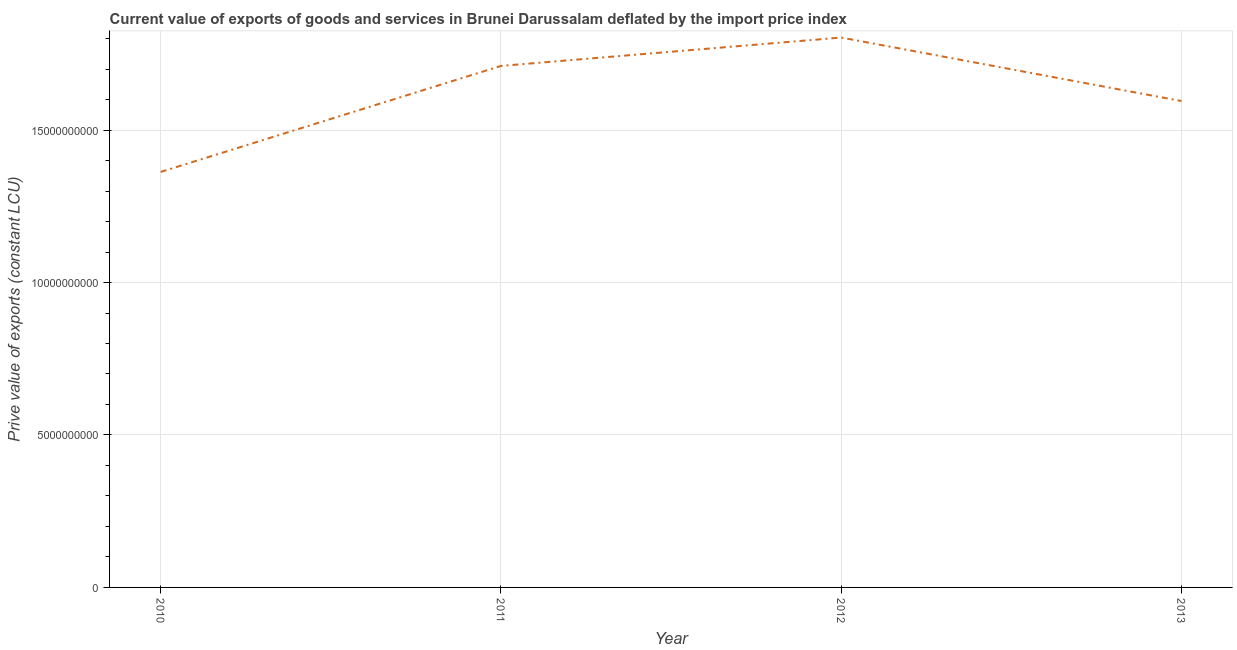What is the price value of exports in 2012?
Ensure brevity in your answer.  1.80e+1. Across all years, what is the maximum price value of exports?
Your answer should be compact. 1.80e+1. Across all years, what is the minimum price value of exports?
Provide a short and direct response. 1.36e+1. In which year was the price value of exports maximum?
Your response must be concise. 2012. In which year was the price value of exports minimum?
Keep it short and to the point. 2010. What is the sum of the price value of exports?
Keep it short and to the point. 6.47e+1. What is the difference between the price value of exports in 2011 and 2012?
Keep it short and to the point. -9.31e+08. What is the average price value of exports per year?
Your answer should be very brief. 1.62e+1. What is the median price value of exports?
Your answer should be compact. 1.65e+1. In how many years, is the price value of exports greater than 1000000000 LCU?
Offer a terse response. 4. What is the ratio of the price value of exports in 2010 to that in 2013?
Your answer should be very brief. 0.85. Is the price value of exports in 2010 less than that in 2013?
Ensure brevity in your answer.  Yes. Is the difference between the price value of exports in 2011 and 2013 greater than the difference between any two years?
Your answer should be compact. No. What is the difference between the highest and the second highest price value of exports?
Offer a very short reply. 9.31e+08. What is the difference between the highest and the lowest price value of exports?
Make the answer very short. 4.41e+09. In how many years, is the price value of exports greater than the average price value of exports taken over all years?
Your answer should be very brief. 2. How many lines are there?
Your response must be concise. 1. What is the difference between two consecutive major ticks on the Y-axis?
Provide a succinct answer. 5.00e+09. Are the values on the major ticks of Y-axis written in scientific E-notation?
Ensure brevity in your answer.  No. Does the graph contain any zero values?
Offer a very short reply. No. Does the graph contain grids?
Make the answer very short. Yes. What is the title of the graph?
Your response must be concise. Current value of exports of goods and services in Brunei Darussalam deflated by the import price index. What is the label or title of the X-axis?
Your answer should be very brief. Year. What is the label or title of the Y-axis?
Offer a very short reply. Prive value of exports (constant LCU). What is the Prive value of exports (constant LCU) of 2010?
Give a very brief answer. 1.36e+1. What is the Prive value of exports (constant LCU) in 2011?
Keep it short and to the point. 1.71e+1. What is the Prive value of exports (constant LCU) in 2012?
Your response must be concise. 1.80e+1. What is the Prive value of exports (constant LCU) of 2013?
Ensure brevity in your answer.  1.60e+1. What is the difference between the Prive value of exports (constant LCU) in 2010 and 2011?
Keep it short and to the point. -3.48e+09. What is the difference between the Prive value of exports (constant LCU) in 2010 and 2012?
Make the answer very short. -4.41e+09. What is the difference between the Prive value of exports (constant LCU) in 2010 and 2013?
Keep it short and to the point. -2.33e+09. What is the difference between the Prive value of exports (constant LCU) in 2011 and 2012?
Offer a very short reply. -9.31e+08. What is the difference between the Prive value of exports (constant LCU) in 2011 and 2013?
Provide a succinct answer. 1.15e+09. What is the difference between the Prive value of exports (constant LCU) in 2012 and 2013?
Ensure brevity in your answer.  2.08e+09. What is the ratio of the Prive value of exports (constant LCU) in 2010 to that in 2011?
Offer a terse response. 0.8. What is the ratio of the Prive value of exports (constant LCU) in 2010 to that in 2012?
Your answer should be very brief. 0.76. What is the ratio of the Prive value of exports (constant LCU) in 2010 to that in 2013?
Provide a succinct answer. 0.85. What is the ratio of the Prive value of exports (constant LCU) in 2011 to that in 2012?
Ensure brevity in your answer.  0.95. What is the ratio of the Prive value of exports (constant LCU) in 2011 to that in 2013?
Offer a very short reply. 1.07. What is the ratio of the Prive value of exports (constant LCU) in 2012 to that in 2013?
Your answer should be very brief. 1.13. 